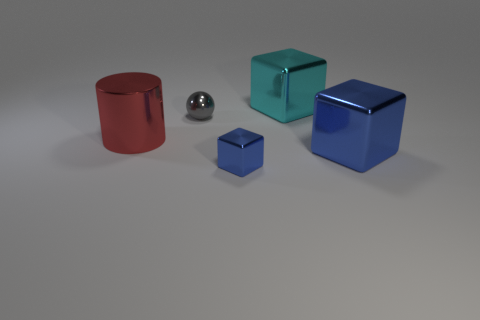There is a large object that is the same color as the tiny metallic block; what material is it?
Ensure brevity in your answer.  Metal. There is another large object that is the same shape as the large blue object; what is its color?
Ensure brevity in your answer.  Cyan. There is a blue metallic cube that is on the left side of the shiny cube that is behind the red object; is there a big shiny object that is to the left of it?
Your answer should be very brief. Yes. Does the large red shiny object have the same shape as the small blue object?
Provide a short and direct response. No. Are there fewer large blue blocks that are to the left of the tiny gray metallic ball than blue shiny things?
Give a very brief answer. Yes. There is a small object behind the blue cube left of the metallic cube that is behind the big shiny cylinder; what color is it?
Make the answer very short. Gray. How many metallic objects are large blue blocks or large cyan blocks?
Ensure brevity in your answer.  2. Do the gray metal sphere and the cyan metal cube have the same size?
Give a very brief answer. No. Is the number of large metal objects in front of the large shiny cylinder less than the number of metallic things that are to the right of the tiny blue object?
Your response must be concise. Yes. What size is the red cylinder?
Your answer should be very brief. Large. 